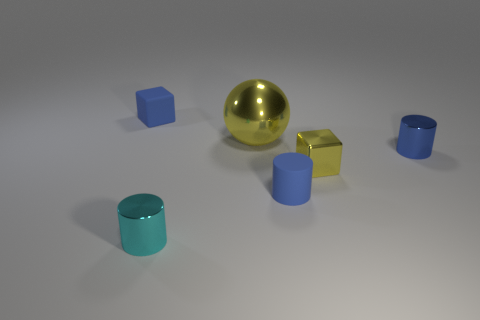Is there anything else that has the same size as the yellow sphere?
Provide a succinct answer. No. Is there a tiny cube that has the same material as the big thing?
Offer a terse response. Yes. There is a yellow block that is the same size as the blue shiny thing; what is its material?
Your answer should be very brief. Metal. Does the tiny block on the left side of the tiny cyan object have the same color as the rubber object to the right of the tiny cyan shiny object?
Your response must be concise. Yes. There is a tiny metallic cylinder that is in front of the tiny blue matte cylinder; is there a tiny object right of it?
Make the answer very short. Yes. Does the tiny object that is left of the cyan object have the same shape as the yellow metal thing in front of the large shiny thing?
Ensure brevity in your answer.  Yes. Do the tiny cube that is right of the tiny cyan cylinder and the small cube that is behind the tiny yellow cube have the same material?
Your response must be concise. No. There is a cube left of the rubber thing to the right of the cyan shiny thing; what is its material?
Your answer should be very brief. Rubber. There is a blue rubber object that is left of the matte object that is right of the block behind the big metal ball; what shape is it?
Make the answer very short. Cube. There is a tiny cyan object that is the same shape as the small blue shiny thing; what is it made of?
Your answer should be compact. Metal. 